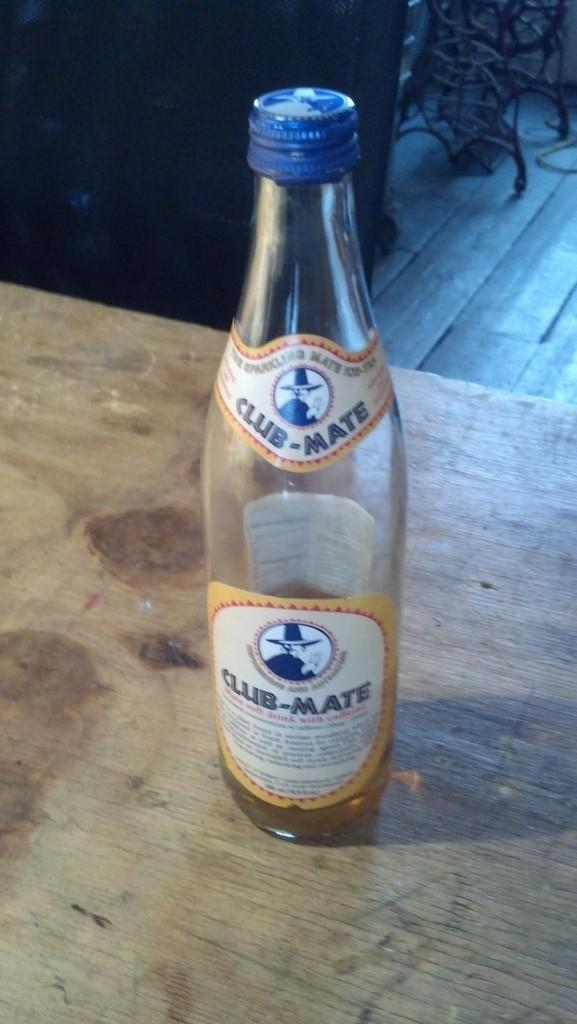What object is placed on the table in the image? There is a bottle on a table in the image. What part of the room can be seen in the image? The floor is visible in the image. Are there any furniture items in the image? Yes, there is a chair in the image. What type of jam is being transported in the fire in the image? There is no jam, fire, or transportation depicted in the image. 